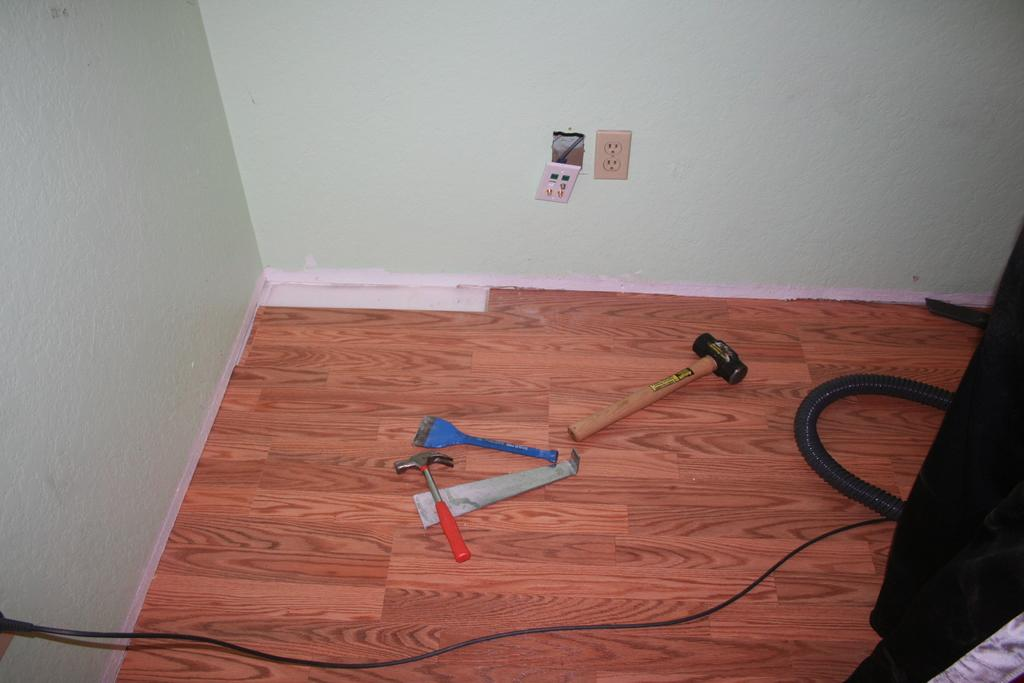What type of room is shown in the image? The image depicts a room. What is the flooring material in the room? There is a wooden floor in the room. What tools or objects can be seen on the floor? There are hammers, a brush, a pipe, and a wire on the floor. What can be seen in the background of the image? There is a wall visible in the background. How many ladybugs are crawling on the wooden floor in the image? There are no ladybugs present in the image; the floor only contains hammers, a brush, a pipe, and a wire. What type of support does the pipe provide in the image? The image does not show the pipe providing any support; it is simply lying on the floor. 